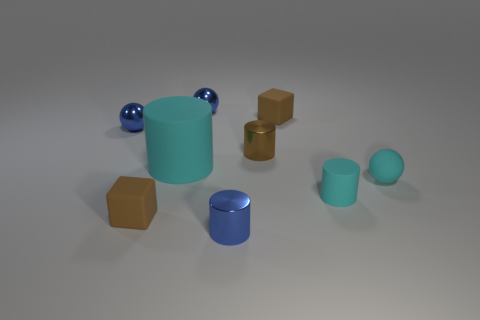Subtract all small cyan matte cylinders. How many cylinders are left? 3 Add 1 cyan rubber spheres. How many objects exist? 10 Subtract all cyan balls. How many balls are left? 2 Subtract all spheres. How many objects are left? 6 Subtract all purple cylinders. How many cyan balls are left? 1 Subtract all tiny metallic balls. Subtract all rubber spheres. How many objects are left? 6 Add 5 brown cubes. How many brown cubes are left? 7 Add 8 brown cylinders. How many brown cylinders exist? 9 Subtract 1 cyan spheres. How many objects are left? 8 Subtract 2 cylinders. How many cylinders are left? 2 